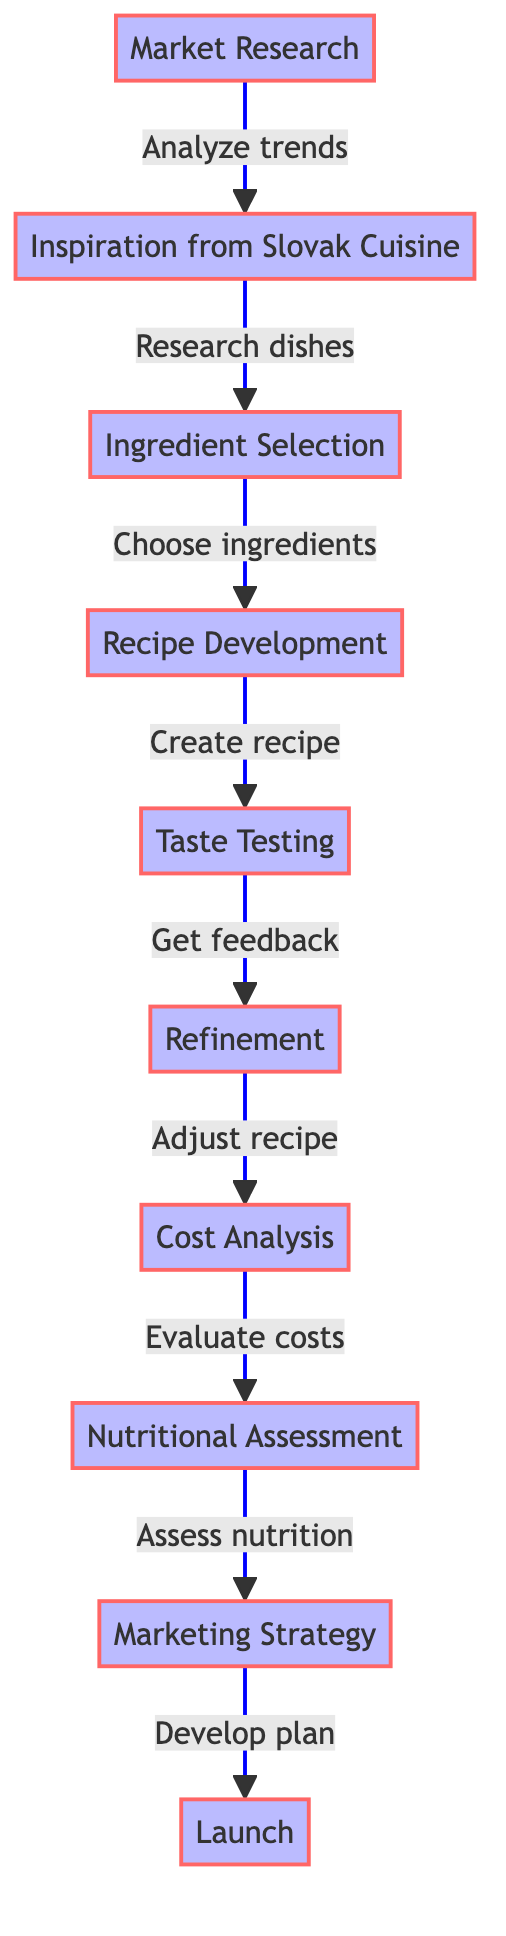What is the first step in designing a new Slovak-inspired dish? The first step according to the diagram is "Market Research", which is identified as the initial node before any other steps.
Answer: Market Research How many nodes are in the diagram? By counting each unique step represented in the diagram, there are ten nodes labeled sequentially from 1 to 10.
Answer: 10 What follows "Taste Testing"? Looking at the directed connections in the diagram, "Refinement" is the next step that follows "Taste Testing".
Answer: Refinement What is the last step in the process? The last step indicated in the diagram is "Launch", which is the final node and does not have any further connections.
Answer: Launch Which node involves analyzing trends? "Market Research" is the node that explicitly mentions analyzing trends in American cuisine and related elements.
Answer: Market Research What are the two steps that directly follow "Ingredient Selection"? The diagram shows that "Ingredient Selection" leads directly to "Recipe Development" and is followed by "Taste Testing".
Answer: Recipe Development and Taste Testing Identify the step where nutritional content is evaluated. The diagram states that "Nutritional Assessment" is the specific step focused on analyzing nutritional content in the dish.
Answer: Nutritional Assessment Which step involves feedback from consumers? During the "Taste Testing" phase, feedback is obtained from a diverse group of American consumers, as indicated in the diagram.
Answer: Taste Testing What is the relationship between "Refinement" and "Cost Analysis"? "Refinement" leads to "Cost Analysis" in the sequence of steps, indicating that improvements made to the recipe precede cost evaluation.
Answer: Refinement leads to Cost Analysis How does the process start? The process begins with "Market Research," which serves as the foundational step for all subsequent actions in designing the dish.
Answer: Market Research 